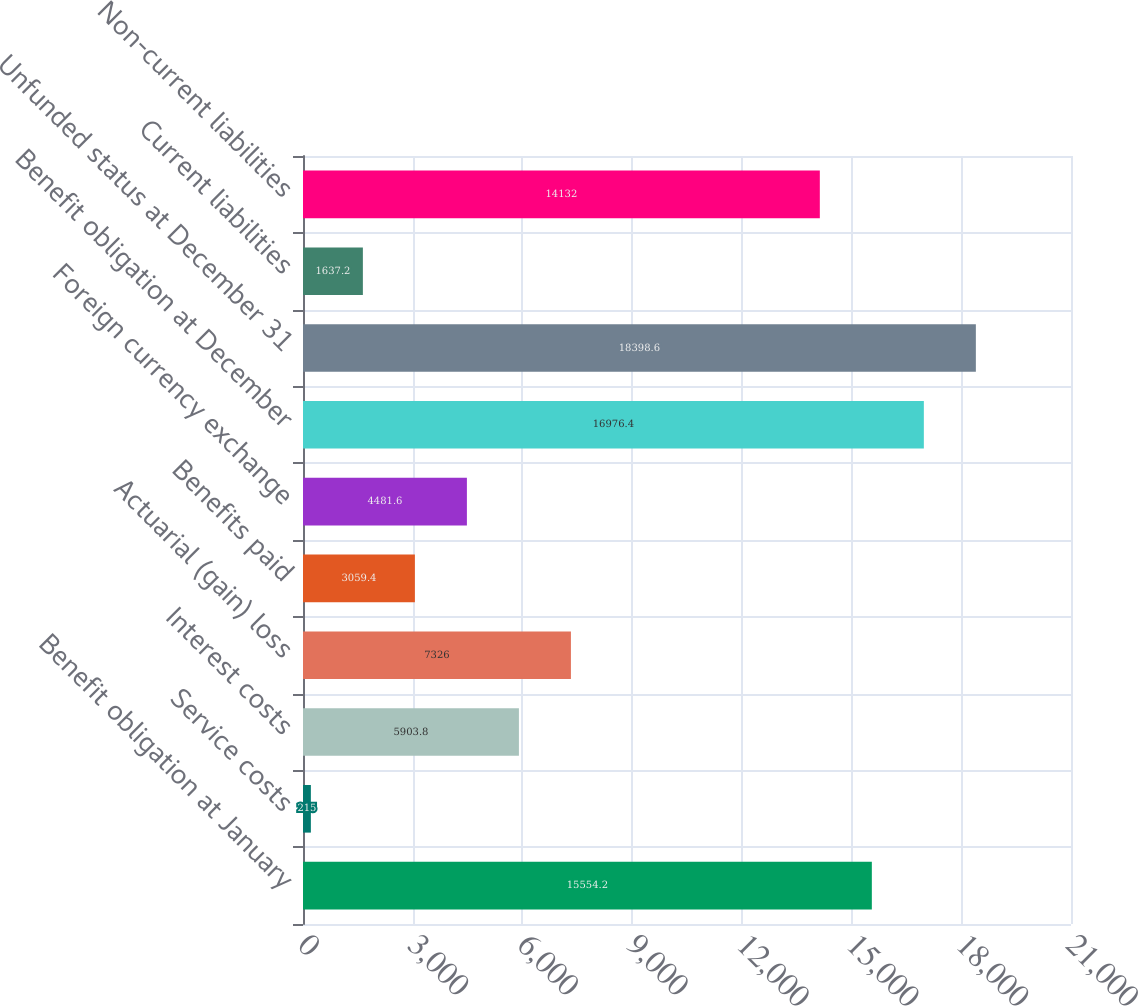Convert chart to OTSL. <chart><loc_0><loc_0><loc_500><loc_500><bar_chart><fcel>Benefit obligation at January<fcel>Service costs<fcel>Interest costs<fcel>Actuarial (gain) loss<fcel>Benefits paid<fcel>Foreign currency exchange<fcel>Benefit obligation at December<fcel>Unfunded status at December 31<fcel>Current liabilities<fcel>Non-current liabilities<nl><fcel>15554.2<fcel>215<fcel>5903.8<fcel>7326<fcel>3059.4<fcel>4481.6<fcel>16976.4<fcel>18398.6<fcel>1637.2<fcel>14132<nl></chart> 